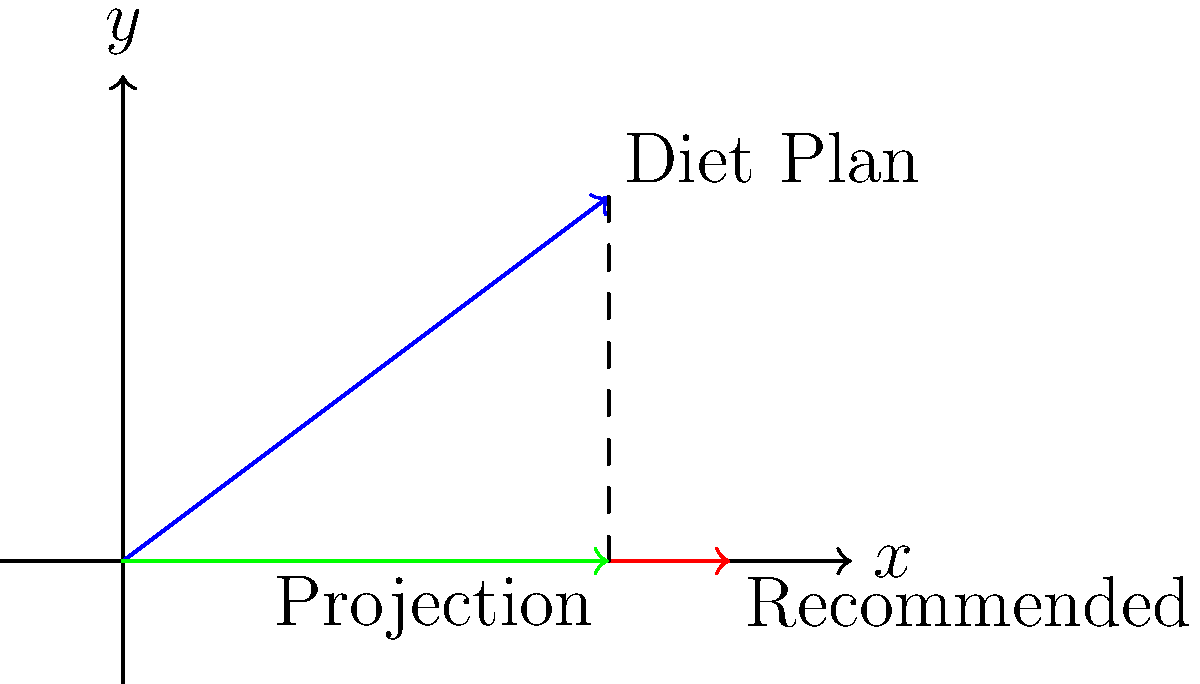A nutritionist has created a diet plan vector $\mathbf{a} = (4, 3)$ representing daily intake of protein (x-axis) and fiber (y-axis) in grams. The recommended nutrition vector based on evidence-based guidelines is $\mathbf{b} = (5, 0)$. Calculate the magnitude of the projection of the diet plan vector onto the recommended nutrition vector. To find the magnitude of the projection of vector $\mathbf{a}$ onto vector $\mathbf{b}$, we'll follow these steps:

1) The formula for vector projection is:
   $\text{proj}_\mathbf{b}\mathbf{a} = \frac{\mathbf{a} \cdot \mathbf{b}}{\|\mathbf{b}\|^2} \mathbf{b}$

2) First, calculate the dot product $\mathbf{a} \cdot \mathbf{b}$:
   $\mathbf{a} \cdot \mathbf{b} = (4)(5) + (3)(0) = 20$

3) Calculate the magnitude of $\mathbf{b}$ squared:
   $\|\mathbf{b}\|^2 = 5^2 + 0^2 = 25$

4) Now, we can find the scalar projection:
   $\frac{\mathbf{a} \cdot \mathbf{b}}{\|\mathbf{b}\|^2} = \frac{20}{25} = 0.8$

5) The vector projection would be:
   $\text{proj}_\mathbf{b}\mathbf{a} = 0.8 \mathbf{b} = 0.8(5, 0) = (4, 0)$

6) The magnitude of this projection is the length of the vector $(4, 0)$:
   $\|\text{proj}_\mathbf{b}\mathbf{a}\| = \sqrt{4^2 + 0^2} = 4$

Therefore, the magnitude of the projection is 4.
Answer: 4 